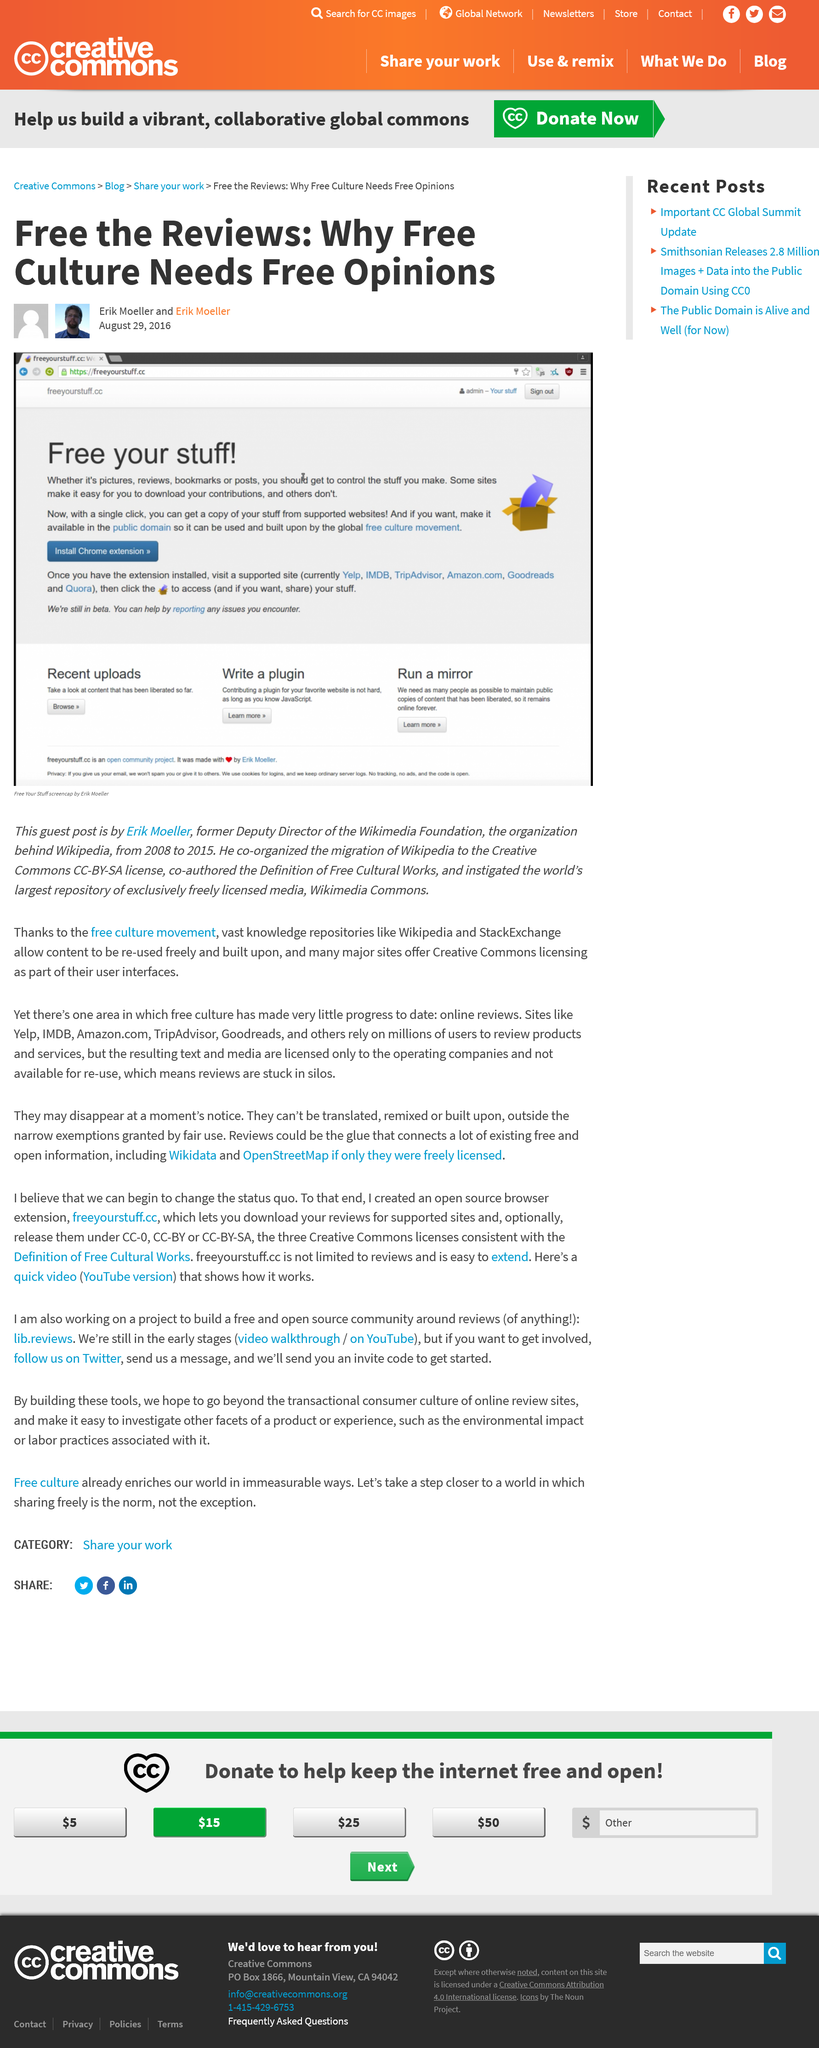Indicate a few pertinent items in this graphic. With just one click, you can obtain a copy of your belongings. Wikimedia Commons is the largest repository of exclusively freely licensed media in the world. Erik Moeller wrote this article in the year following his departure from the Wikimedia Foundation. 